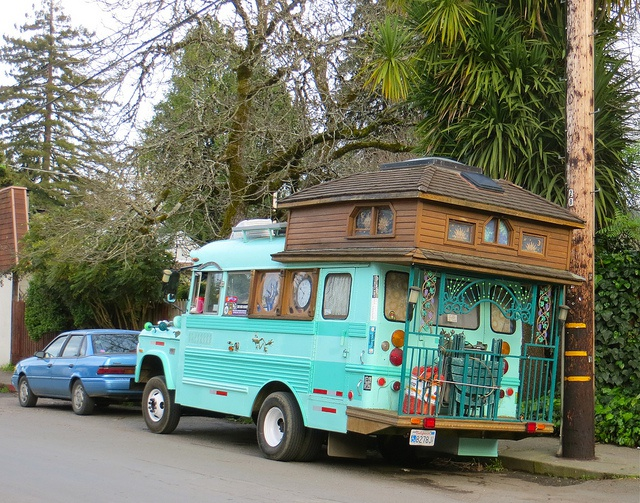Describe the objects in this image and their specific colors. I can see bus in white, turquoise, black, and gray tones, truck in white, turquoise, black, and gray tones, car in white, black, gray, and lightblue tones, and clock in white, lightblue, gray, and darkgray tones in this image. 